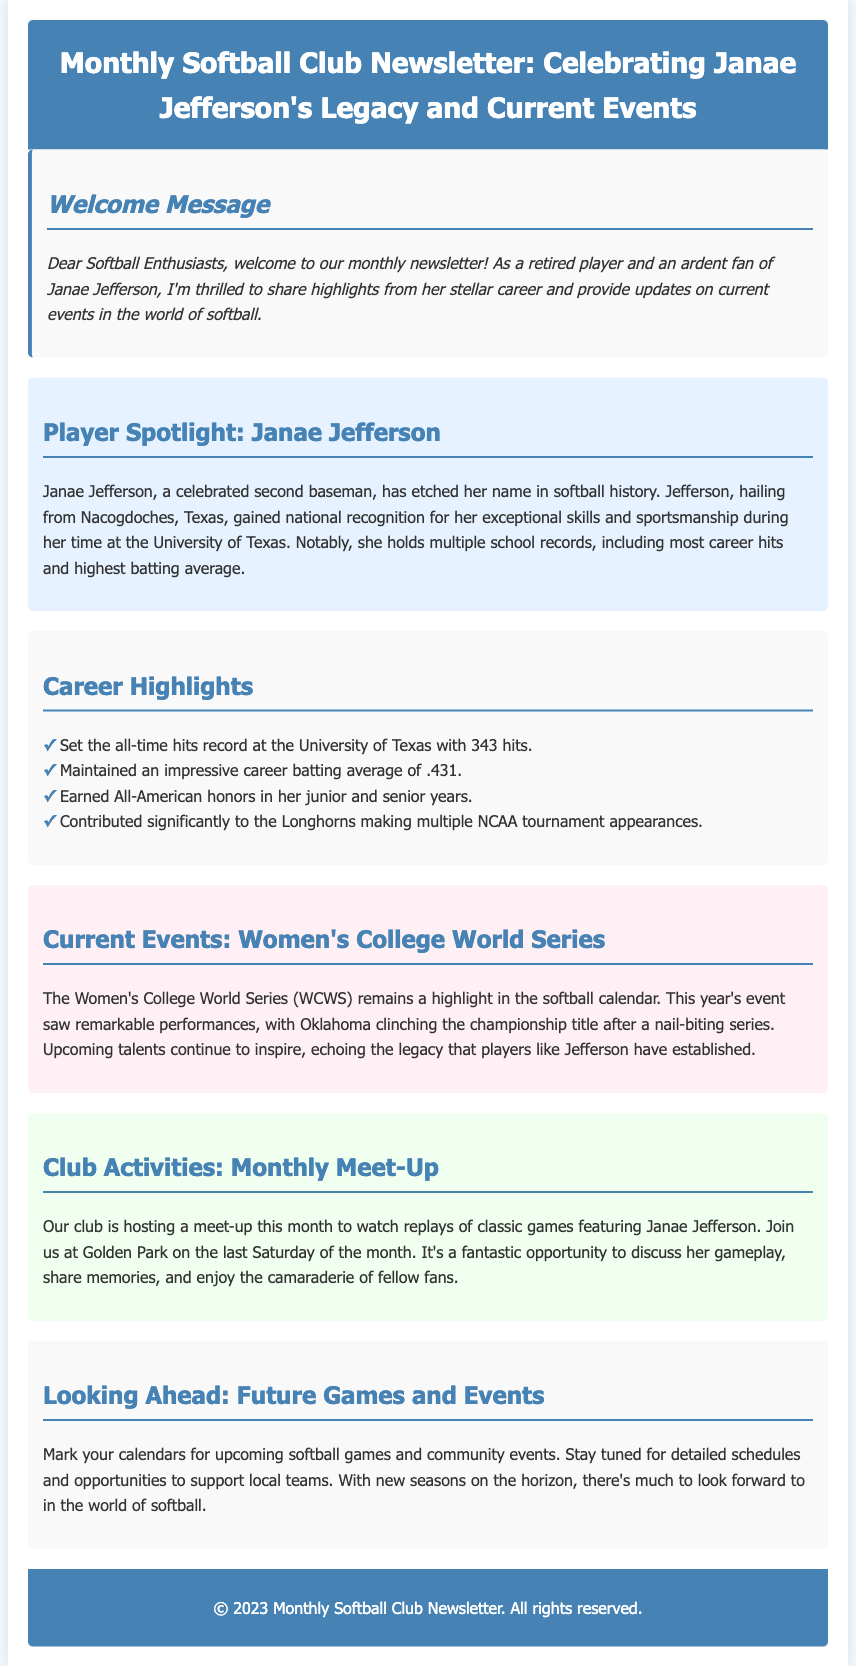what is the title of the newsletter? The title is provided in the header of the document and is "Monthly Softball Club Newsletter: Celebrating Janae Jefferson's Legacy and Current Events."
Answer: Monthly Softball Club Newsletter: Celebrating Janae Jefferson's Legacy and Current Events who is the player spotlighted in the newsletter? The newsletter highlights Janae Jefferson, a second baseman.
Answer: Janae Jefferson how many hits did Janae Jefferson record at the University of Texas? The document states that Janae Jefferson set the all-time hits record with 343 hits.
Answer: 343 hits what was Janae Jefferson's career batting average? The newsletter mentions that she maintained a career batting average of .431.
Answer: .431 when is the club's monthly meet-up scheduled? The document specifies that the meet-up is on the last Saturday of the month.
Answer: Last Saturday of the month which team won the Women's College World Series this year? The document indicates that Oklahoma clinched the championship title.
Answer: Oklahoma how many times did Janae Jefferson earn All-American honors? The document states that she earned All-American honors in her junior and senior years, which is two times.
Answer: Two times what significant event does the newsletter encourage members to participate in? The newsletter encourages members to join the meet-up to watch replays of classic games featuring Janae Jefferson.
Answer: Watch replays of classic games what type of events does the newsletter reference looking ahead? The newsletter mentions upcoming softball games and community events.
Answer: Softball games and community events 